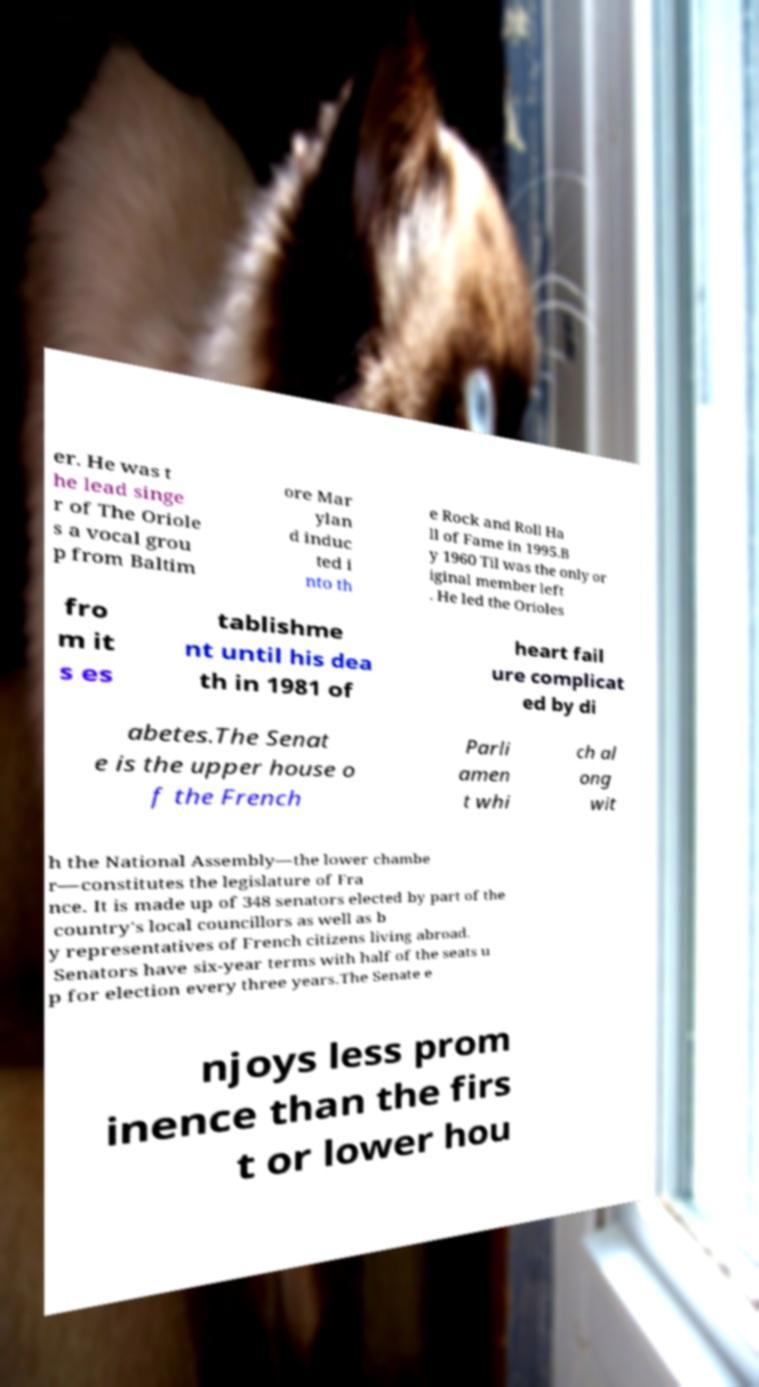What messages or text are displayed in this image? I need them in a readable, typed format. er. He was t he lead singe r of The Oriole s a vocal grou p from Baltim ore Mar ylan d induc ted i nto th e Rock and Roll Ha ll of Fame in 1995.B y 1960 Til was the only or iginal member left . He led the Orioles fro m it s es tablishme nt until his dea th in 1981 of heart fail ure complicat ed by di abetes.The Senat e is the upper house o f the French Parli amen t whi ch al ong wit h the National Assembly—the lower chambe r—constitutes the legislature of Fra nce. It is made up of 348 senators elected by part of the country's local councillors as well as b y representatives of French citizens living abroad. Senators have six-year terms with half of the seats u p for election every three years.The Senate e njoys less prom inence than the firs t or lower hou 